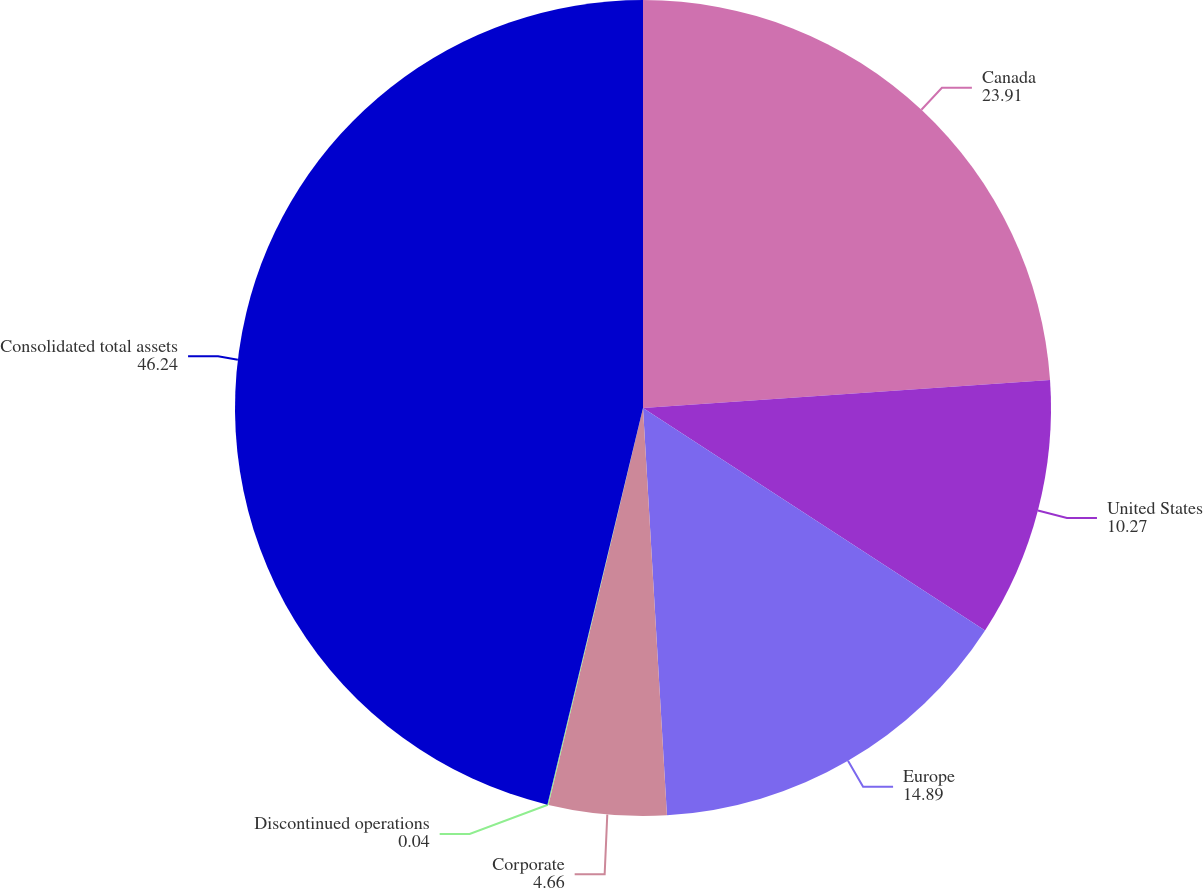Convert chart. <chart><loc_0><loc_0><loc_500><loc_500><pie_chart><fcel>Canada<fcel>United States<fcel>Europe<fcel>Corporate<fcel>Discontinued operations<fcel>Consolidated total assets<nl><fcel>23.91%<fcel>10.27%<fcel>14.89%<fcel>4.66%<fcel>0.04%<fcel>46.24%<nl></chart> 